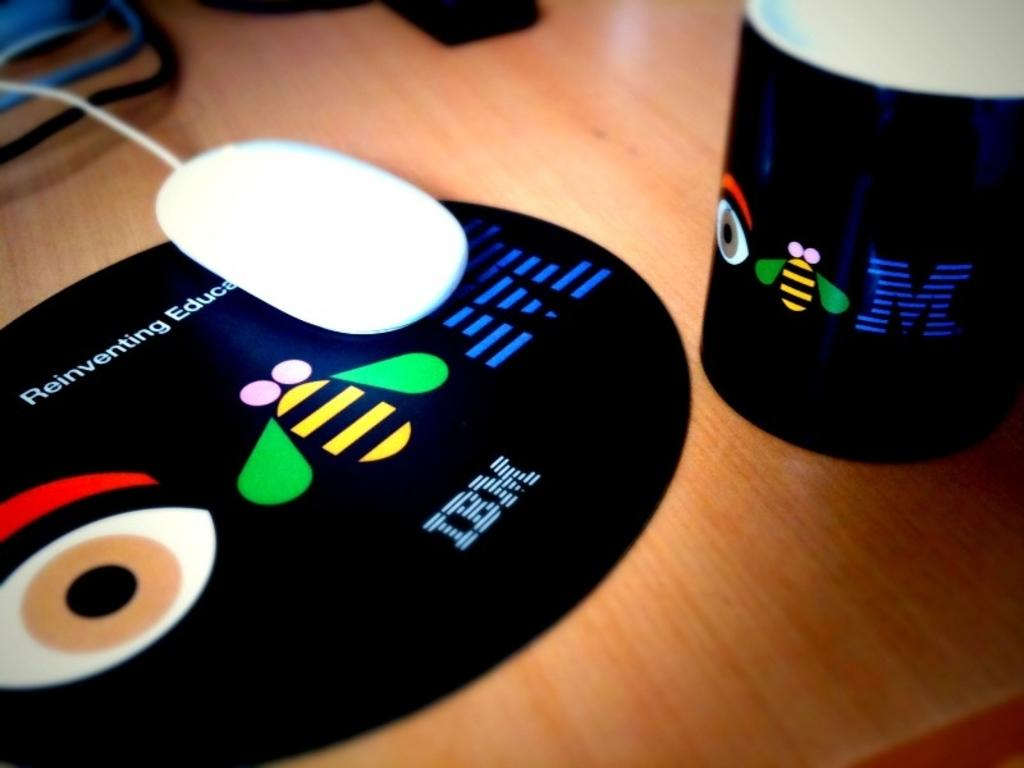<image>
Present a compact description of the photo's key features. Black CD for IBM next to another black object. 